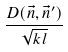<formula> <loc_0><loc_0><loc_500><loc_500>\frac { D ( \vec { n } , \vec { n } ^ { \prime } ) } { \sqrt { k l } }</formula> 